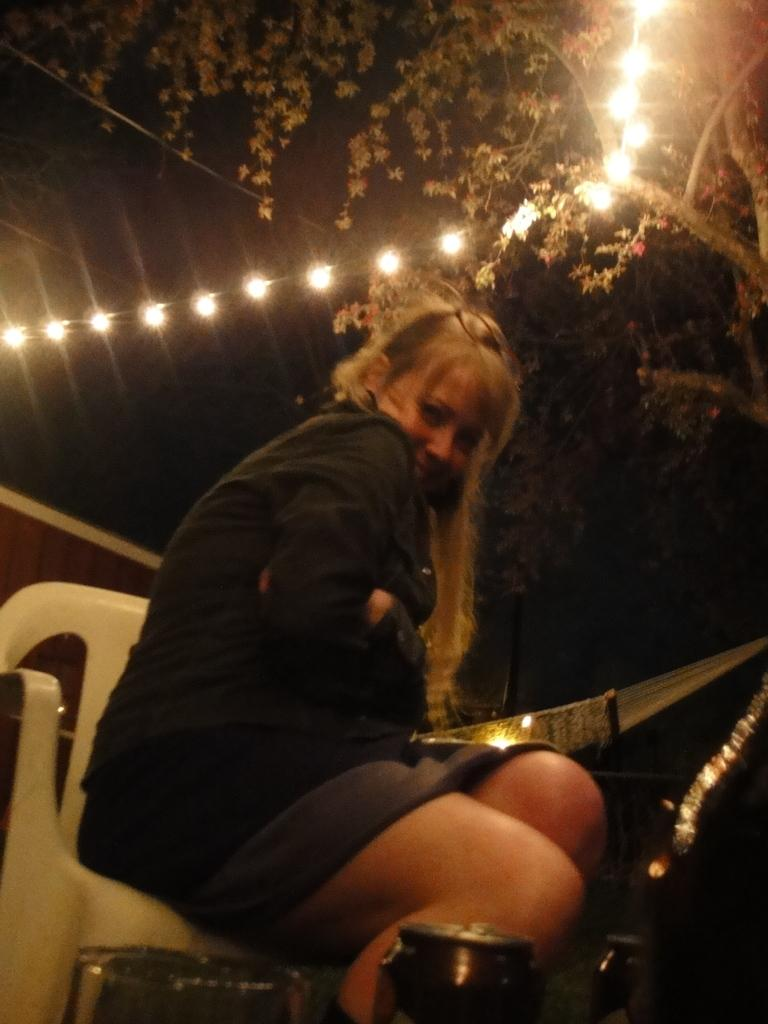Who is present in the image? There is a woman in the image. What is the woman doing in the image? The woman is sitting on a chair in the image. What object is in front of the woman? There is a can in front of the woman. What can be seen behind the woman? There is a tree with decorative lights behind the woman. What type of ship can be seen sailing in the background of the image? There is no ship present in the image; it features a woman sitting on a chair with a tree and decorative lights behind her. 